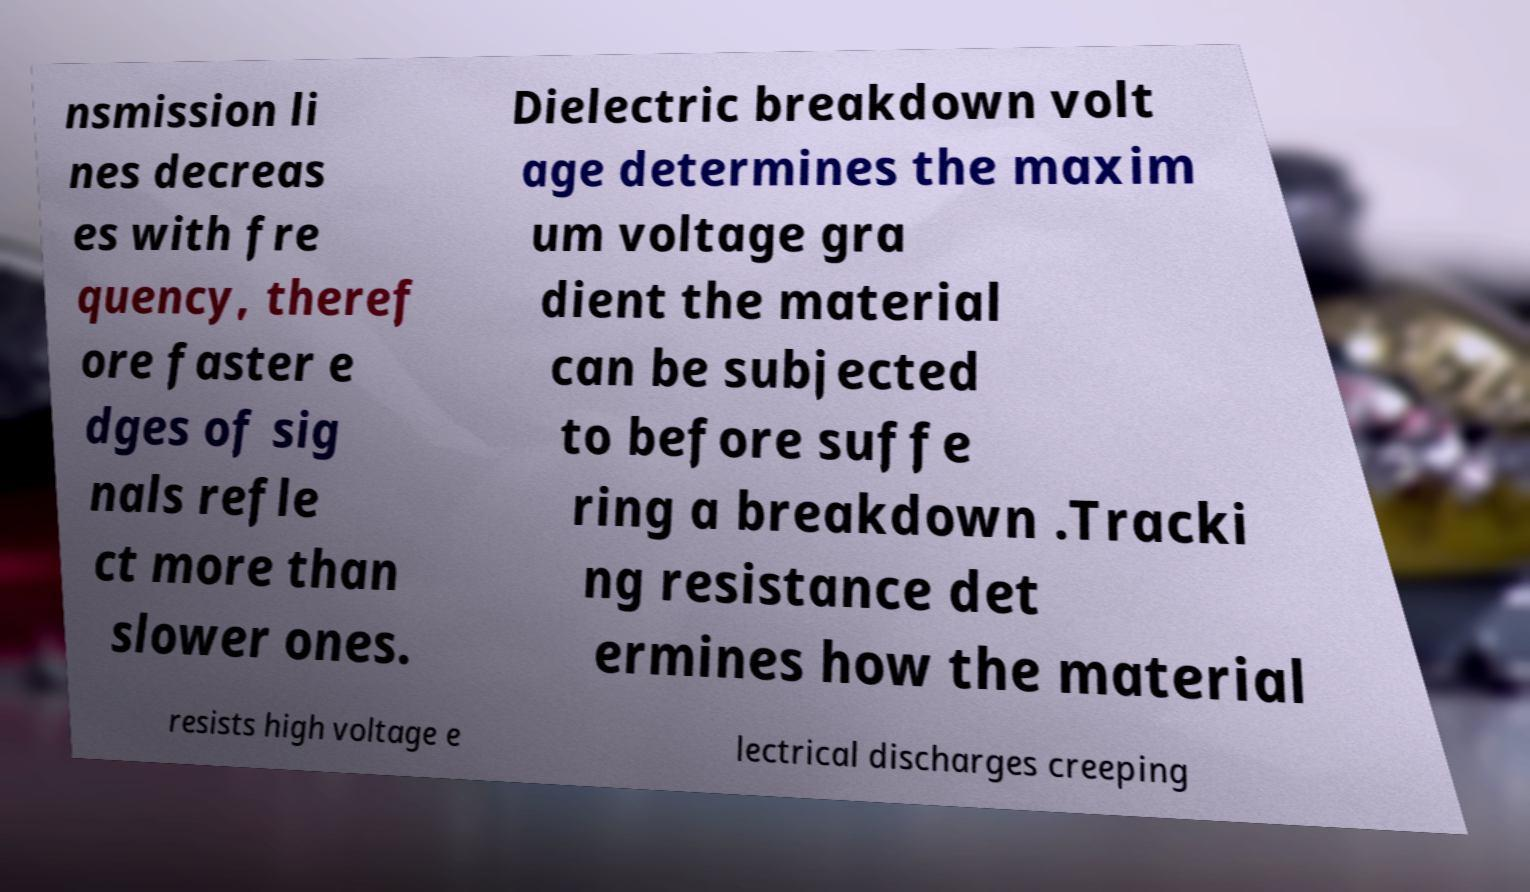Please read and relay the text visible in this image. What does it say? nsmission li nes decreas es with fre quency, theref ore faster e dges of sig nals refle ct more than slower ones. Dielectric breakdown volt age determines the maxim um voltage gra dient the material can be subjected to before suffe ring a breakdown .Tracki ng resistance det ermines how the material resists high voltage e lectrical discharges creeping 